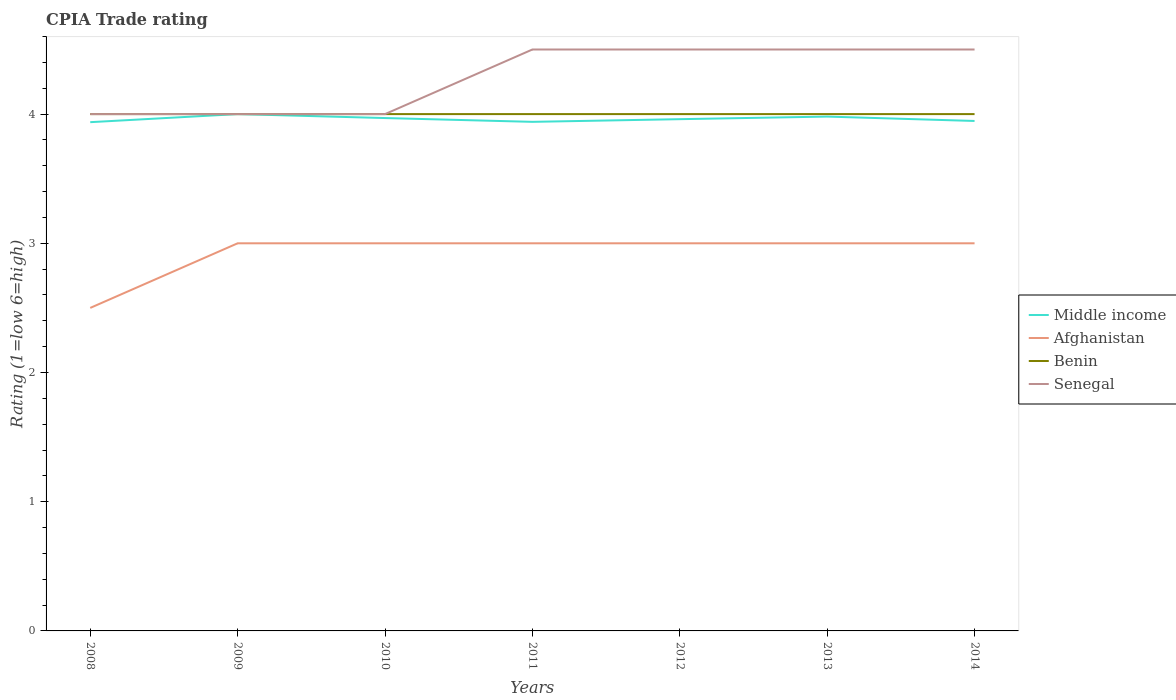How many different coloured lines are there?
Your answer should be very brief. 4. Does the line corresponding to Benin intersect with the line corresponding to Middle income?
Keep it short and to the point. Yes. Is the number of lines equal to the number of legend labels?
Offer a terse response. Yes. Across all years, what is the maximum CPIA rating in Senegal?
Your response must be concise. 4. In which year was the CPIA rating in Afghanistan maximum?
Your response must be concise. 2008. What is the difference between the highest and the second highest CPIA rating in Benin?
Your response must be concise. 0. What is the difference between the highest and the lowest CPIA rating in Middle income?
Provide a succinct answer. 3. Is the CPIA rating in Senegal strictly greater than the CPIA rating in Afghanistan over the years?
Your response must be concise. No. Does the graph contain any zero values?
Ensure brevity in your answer.  No. Where does the legend appear in the graph?
Provide a short and direct response. Center right. How many legend labels are there?
Provide a short and direct response. 4. How are the legend labels stacked?
Provide a short and direct response. Vertical. What is the title of the graph?
Provide a short and direct response. CPIA Trade rating. What is the label or title of the X-axis?
Your response must be concise. Years. What is the Rating (1=low 6=high) in Middle income in 2008?
Make the answer very short. 3.94. What is the Rating (1=low 6=high) in Afghanistan in 2008?
Make the answer very short. 2.5. What is the Rating (1=low 6=high) of Middle income in 2009?
Provide a succinct answer. 4. What is the Rating (1=low 6=high) of Afghanistan in 2009?
Provide a short and direct response. 3. What is the Rating (1=low 6=high) in Benin in 2009?
Provide a succinct answer. 4. What is the Rating (1=low 6=high) of Senegal in 2009?
Provide a succinct answer. 4. What is the Rating (1=low 6=high) in Middle income in 2010?
Provide a short and direct response. 3.97. What is the Rating (1=low 6=high) of Afghanistan in 2010?
Keep it short and to the point. 3. What is the Rating (1=low 6=high) in Middle income in 2011?
Your answer should be compact. 3.94. What is the Rating (1=low 6=high) in Afghanistan in 2011?
Ensure brevity in your answer.  3. What is the Rating (1=low 6=high) of Senegal in 2011?
Offer a terse response. 4.5. What is the Rating (1=low 6=high) of Middle income in 2012?
Your response must be concise. 3.96. What is the Rating (1=low 6=high) in Afghanistan in 2012?
Keep it short and to the point. 3. What is the Rating (1=low 6=high) of Benin in 2012?
Provide a succinct answer. 4. What is the Rating (1=low 6=high) of Middle income in 2013?
Your answer should be compact. 3.98. What is the Rating (1=low 6=high) in Benin in 2013?
Your answer should be very brief. 4. What is the Rating (1=low 6=high) of Middle income in 2014?
Offer a terse response. 3.95. What is the Rating (1=low 6=high) in Benin in 2014?
Provide a short and direct response. 4. What is the Rating (1=low 6=high) of Senegal in 2014?
Give a very brief answer. 4.5. Across all years, what is the maximum Rating (1=low 6=high) in Middle income?
Make the answer very short. 4. Across all years, what is the minimum Rating (1=low 6=high) of Middle income?
Your answer should be very brief. 3.94. Across all years, what is the minimum Rating (1=low 6=high) in Senegal?
Offer a very short reply. 4. What is the total Rating (1=low 6=high) of Middle income in the graph?
Make the answer very short. 27.74. What is the difference between the Rating (1=low 6=high) in Middle income in 2008 and that in 2009?
Keep it short and to the point. -0.06. What is the difference between the Rating (1=low 6=high) in Afghanistan in 2008 and that in 2009?
Your answer should be compact. -0.5. What is the difference between the Rating (1=low 6=high) of Middle income in 2008 and that in 2010?
Offer a terse response. -0.03. What is the difference between the Rating (1=low 6=high) of Afghanistan in 2008 and that in 2010?
Your answer should be very brief. -0.5. What is the difference between the Rating (1=low 6=high) in Benin in 2008 and that in 2010?
Offer a terse response. 0. What is the difference between the Rating (1=low 6=high) of Senegal in 2008 and that in 2010?
Your response must be concise. 0. What is the difference between the Rating (1=low 6=high) of Middle income in 2008 and that in 2011?
Your answer should be very brief. -0. What is the difference between the Rating (1=low 6=high) of Middle income in 2008 and that in 2012?
Provide a succinct answer. -0.02. What is the difference between the Rating (1=low 6=high) in Benin in 2008 and that in 2012?
Offer a terse response. 0. What is the difference between the Rating (1=low 6=high) in Middle income in 2008 and that in 2013?
Your answer should be compact. -0.04. What is the difference between the Rating (1=low 6=high) in Afghanistan in 2008 and that in 2013?
Offer a very short reply. -0.5. What is the difference between the Rating (1=low 6=high) of Benin in 2008 and that in 2013?
Make the answer very short. 0. What is the difference between the Rating (1=low 6=high) of Middle income in 2008 and that in 2014?
Your answer should be compact. -0.01. What is the difference between the Rating (1=low 6=high) of Afghanistan in 2008 and that in 2014?
Your answer should be compact. -0.5. What is the difference between the Rating (1=low 6=high) of Middle income in 2009 and that in 2010?
Make the answer very short. 0.03. What is the difference between the Rating (1=low 6=high) of Benin in 2009 and that in 2010?
Your answer should be compact. 0. What is the difference between the Rating (1=low 6=high) of Benin in 2009 and that in 2011?
Offer a terse response. 0. What is the difference between the Rating (1=low 6=high) in Senegal in 2009 and that in 2011?
Your response must be concise. -0.5. What is the difference between the Rating (1=low 6=high) in Middle income in 2009 and that in 2012?
Your response must be concise. 0.04. What is the difference between the Rating (1=low 6=high) of Afghanistan in 2009 and that in 2012?
Provide a succinct answer. 0. What is the difference between the Rating (1=low 6=high) of Senegal in 2009 and that in 2012?
Keep it short and to the point. -0.5. What is the difference between the Rating (1=low 6=high) in Middle income in 2009 and that in 2013?
Offer a terse response. 0.02. What is the difference between the Rating (1=low 6=high) of Afghanistan in 2009 and that in 2013?
Keep it short and to the point. 0. What is the difference between the Rating (1=low 6=high) in Benin in 2009 and that in 2013?
Provide a short and direct response. 0. What is the difference between the Rating (1=low 6=high) in Senegal in 2009 and that in 2013?
Keep it short and to the point. -0.5. What is the difference between the Rating (1=low 6=high) of Middle income in 2009 and that in 2014?
Offer a terse response. 0.05. What is the difference between the Rating (1=low 6=high) of Afghanistan in 2009 and that in 2014?
Offer a very short reply. 0. What is the difference between the Rating (1=low 6=high) in Benin in 2009 and that in 2014?
Offer a terse response. 0. What is the difference between the Rating (1=low 6=high) in Senegal in 2009 and that in 2014?
Provide a short and direct response. -0.5. What is the difference between the Rating (1=low 6=high) of Middle income in 2010 and that in 2011?
Provide a succinct answer. 0.03. What is the difference between the Rating (1=low 6=high) in Benin in 2010 and that in 2011?
Your answer should be compact. 0. What is the difference between the Rating (1=low 6=high) of Senegal in 2010 and that in 2011?
Ensure brevity in your answer.  -0.5. What is the difference between the Rating (1=low 6=high) in Middle income in 2010 and that in 2012?
Offer a very short reply. 0.01. What is the difference between the Rating (1=low 6=high) in Senegal in 2010 and that in 2012?
Ensure brevity in your answer.  -0.5. What is the difference between the Rating (1=low 6=high) of Middle income in 2010 and that in 2013?
Your response must be concise. -0.01. What is the difference between the Rating (1=low 6=high) in Afghanistan in 2010 and that in 2013?
Ensure brevity in your answer.  0. What is the difference between the Rating (1=low 6=high) of Benin in 2010 and that in 2013?
Your answer should be very brief. 0. What is the difference between the Rating (1=low 6=high) of Middle income in 2010 and that in 2014?
Your answer should be very brief. 0.02. What is the difference between the Rating (1=low 6=high) in Afghanistan in 2010 and that in 2014?
Your response must be concise. 0. What is the difference between the Rating (1=low 6=high) in Benin in 2010 and that in 2014?
Your answer should be very brief. 0. What is the difference between the Rating (1=low 6=high) in Senegal in 2010 and that in 2014?
Keep it short and to the point. -0.5. What is the difference between the Rating (1=low 6=high) of Middle income in 2011 and that in 2012?
Provide a succinct answer. -0.02. What is the difference between the Rating (1=low 6=high) of Senegal in 2011 and that in 2012?
Offer a terse response. 0. What is the difference between the Rating (1=low 6=high) in Middle income in 2011 and that in 2013?
Your answer should be compact. -0.04. What is the difference between the Rating (1=low 6=high) in Afghanistan in 2011 and that in 2013?
Keep it short and to the point. 0. What is the difference between the Rating (1=low 6=high) of Middle income in 2011 and that in 2014?
Offer a terse response. -0.01. What is the difference between the Rating (1=low 6=high) of Senegal in 2011 and that in 2014?
Provide a succinct answer. 0. What is the difference between the Rating (1=low 6=high) in Middle income in 2012 and that in 2013?
Offer a terse response. -0.02. What is the difference between the Rating (1=low 6=high) in Afghanistan in 2012 and that in 2013?
Provide a succinct answer. 0. What is the difference between the Rating (1=low 6=high) of Benin in 2012 and that in 2013?
Offer a very short reply. 0. What is the difference between the Rating (1=low 6=high) of Senegal in 2012 and that in 2013?
Provide a short and direct response. 0. What is the difference between the Rating (1=low 6=high) in Middle income in 2012 and that in 2014?
Your answer should be very brief. 0.01. What is the difference between the Rating (1=low 6=high) of Benin in 2012 and that in 2014?
Offer a terse response. 0. What is the difference between the Rating (1=low 6=high) in Middle income in 2013 and that in 2014?
Your answer should be compact. 0.03. What is the difference between the Rating (1=low 6=high) of Afghanistan in 2013 and that in 2014?
Your response must be concise. 0. What is the difference between the Rating (1=low 6=high) in Benin in 2013 and that in 2014?
Ensure brevity in your answer.  0. What is the difference between the Rating (1=low 6=high) of Middle income in 2008 and the Rating (1=low 6=high) of Afghanistan in 2009?
Your answer should be very brief. 0.94. What is the difference between the Rating (1=low 6=high) in Middle income in 2008 and the Rating (1=low 6=high) in Benin in 2009?
Provide a short and direct response. -0.06. What is the difference between the Rating (1=low 6=high) in Middle income in 2008 and the Rating (1=low 6=high) in Senegal in 2009?
Offer a terse response. -0.06. What is the difference between the Rating (1=low 6=high) in Afghanistan in 2008 and the Rating (1=low 6=high) in Senegal in 2009?
Your response must be concise. -1.5. What is the difference between the Rating (1=low 6=high) in Middle income in 2008 and the Rating (1=low 6=high) in Afghanistan in 2010?
Your response must be concise. 0.94. What is the difference between the Rating (1=low 6=high) of Middle income in 2008 and the Rating (1=low 6=high) of Benin in 2010?
Offer a terse response. -0.06. What is the difference between the Rating (1=low 6=high) in Middle income in 2008 and the Rating (1=low 6=high) in Senegal in 2010?
Make the answer very short. -0.06. What is the difference between the Rating (1=low 6=high) of Benin in 2008 and the Rating (1=low 6=high) of Senegal in 2010?
Offer a terse response. 0. What is the difference between the Rating (1=low 6=high) in Middle income in 2008 and the Rating (1=low 6=high) in Afghanistan in 2011?
Make the answer very short. 0.94. What is the difference between the Rating (1=low 6=high) of Middle income in 2008 and the Rating (1=low 6=high) of Benin in 2011?
Provide a short and direct response. -0.06. What is the difference between the Rating (1=low 6=high) of Middle income in 2008 and the Rating (1=low 6=high) of Senegal in 2011?
Your answer should be very brief. -0.56. What is the difference between the Rating (1=low 6=high) of Afghanistan in 2008 and the Rating (1=low 6=high) of Benin in 2011?
Offer a terse response. -1.5. What is the difference between the Rating (1=low 6=high) in Afghanistan in 2008 and the Rating (1=low 6=high) in Senegal in 2011?
Make the answer very short. -2. What is the difference between the Rating (1=low 6=high) in Middle income in 2008 and the Rating (1=low 6=high) in Benin in 2012?
Provide a short and direct response. -0.06. What is the difference between the Rating (1=low 6=high) of Middle income in 2008 and the Rating (1=low 6=high) of Senegal in 2012?
Keep it short and to the point. -0.56. What is the difference between the Rating (1=low 6=high) in Afghanistan in 2008 and the Rating (1=low 6=high) in Benin in 2012?
Give a very brief answer. -1.5. What is the difference between the Rating (1=low 6=high) in Middle income in 2008 and the Rating (1=low 6=high) in Benin in 2013?
Make the answer very short. -0.06. What is the difference between the Rating (1=low 6=high) of Middle income in 2008 and the Rating (1=low 6=high) of Senegal in 2013?
Your answer should be compact. -0.56. What is the difference between the Rating (1=low 6=high) of Afghanistan in 2008 and the Rating (1=low 6=high) of Benin in 2013?
Give a very brief answer. -1.5. What is the difference between the Rating (1=low 6=high) of Afghanistan in 2008 and the Rating (1=low 6=high) of Senegal in 2013?
Provide a short and direct response. -2. What is the difference between the Rating (1=low 6=high) of Benin in 2008 and the Rating (1=low 6=high) of Senegal in 2013?
Your answer should be compact. -0.5. What is the difference between the Rating (1=low 6=high) in Middle income in 2008 and the Rating (1=low 6=high) in Benin in 2014?
Your answer should be very brief. -0.06. What is the difference between the Rating (1=low 6=high) of Middle income in 2008 and the Rating (1=low 6=high) of Senegal in 2014?
Provide a short and direct response. -0.56. What is the difference between the Rating (1=low 6=high) of Afghanistan in 2008 and the Rating (1=low 6=high) of Senegal in 2014?
Make the answer very short. -2. What is the difference between the Rating (1=low 6=high) of Middle income in 2009 and the Rating (1=low 6=high) of Benin in 2010?
Give a very brief answer. 0. What is the difference between the Rating (1=low 6=high) of Middle income in 2009 and the Rating (1=low 6=high) of Senegal in 2010?
Provide a succinct answer. 0. What is the difference between the Rating (1=low 6=high) of Afghanistan in 2009 and the Rating (1=low 6=high) of Senegal in 2010?
Your response must be concise. -1. What is the difference between the Rating (1=low 6=high) in Benin in 2009 and the Rating (1=low 6=high) in Senegal in 2010?
Your answer should be compact. 0. What is the difference between the Rating (1=low 6=high) in Middle income in 2009 and the Rating (1=low 6=high) in Benin in 2011?
Provide a succinct answer. 0. What is the difference between the Rating (1=low 6=high) of Middle income in 2009 and the Rating (1=low 6=high) of Senegal in 2011?
Your response must be concise. -0.5. What is the difference between the Rating (1=low 6=high) in Afghanistan in 2009 and the Rating (1=low 6=high) in Senegal in 2011?
Your response must be concise. -1.5. What is the difference between the Rating (1=low 6=high) in Benin in 2009 and the Rating (1=low 6=high) in Senegal in 2011?
Offer a terse response. -0.5. What is the difference between the Rating (1=low 6=high) of Middle income in 2009 and the Rating (1=low 6=high) of Senegal in 2012?
Keep it short and to the point. -0.5. What is the difference between the Rating (1=low 6=high) in Afghanistan in 2009 and the Rating (1=low 6=high) in Senegal in 2012?
Your answer should be compact. -1.5. What is the difference between the Rating (1=low 6=high) of Benin in 2009 and the Rating (1=low 6=high) of Senegal in 2012?
Offer a terse response. -0.5. What is the difference between the Rating (1=low 6=high) of Middle income in 2009 and the Rating (1=low 6=high) of Afghanistan in 2013?
Provide a succinct answer. 1. What is the difference between the Rating (1=low 6=high) in Afghanistan in 2009 and the Rating (1=low 6=high) in Benin in 2013?
Provide a short and direct response. -1. What is the difference between the Rating (1=low 6=high) of Afghanistan in 2009 and the Rating (1=low 6=high) of Senegal in 2013?
Your answer should be very brief. -1.5. What is the difference between the Rating (1=low 6=high) in Middle income in 2009 and the Rating (1=low 6=high) in Benin in 2014?
Make the answer very short. 0. What is the difference between the Rating (1=low 6=high) in Middle income in 2009 and the Rating (1=low 6=high) in Senegal in 2014?
Keep it short and to the point. -0.5. What is the difference between the Rating (1=low 6=high) in Afghanistan in 2009 and the Rating (1=low 6=high) in Benin in 2014?
Your answer should be very brief. -1. What is the difference between the Rating (1=low 6=high) in Afghanistan in 2009 and the Rating (1=low 6=high) in Senegal in 2014?
Give a very brief answer. -1.5. What is the difference between the Rating (1=low 6=high) of Middle income in 2010 and the Rating (1=low 6=high) of Afghanistan in 2011?
Make the answer very short. 0.97. What is the difference between the Rating (1=low 6=high) of Middle income in 2010 and the Rating (1=low 6=high) of Benin in 2011?
Make the answer very short. -0.03. What is the difference between the Rating (1=low 6=high) in Middle income in 2010 and the Rating (1=low 6=high) in Senegal in 2011?
Provide a short and direct response. -0.53. What is the difference between the Rating (1=low 6=high) of Afghanistan in 2010 and the Rating (1=low 6=high) of Benin in 2011?
Make the answer very short. -1. What is the difference between the Rating (1=low 6=high) of Middle income in 2010 and the Rating (1=low 6=high) of Afghanistan in 2012?
Provide a succinct answer. 0.97. What is the difference between the Rating (1=low 6=high) in Middle income in 2010 and the Rating (1=low 6=high) in Benin in 2012?
Provide a short and direct response. -0.03. What is the difference between the Rating (1=low 6=high) in Middle income in 2010 and the Rating (1=low 6=high) in Senegal in 2012?
Your answer should be very brief. -0.53. What is the difference between the Rating (1=low 6=high) of Afghanistan in 2010 and the Rating (1=low 6=high) of Benin in 2012?
Your response must be concise. -1. What is the difference between the Rating (1=low 6=high) in Benin in 2010 and the Rating (1=low 6=high) in Senegal in 2012?
Your response must be concise. -0.5. What is the difference between the Rating (1=low 6=high) in Middle income in 2010 and the Rating (1=low 6=high) in Afghanistan in 2013?
Ensure brevity in your answer.  0.97. What is the difference between the Rating (1=low 6=high) of Middle income in 2010 and the Rating (1=low 6=high) of Benin in 2013?
Offer a terse response. -0.03. What is the difference between the Rating (1=low 6=high) of Middle income in 2010 and the Rating (1=low 6=high) of Senegal in 2013?
Keep it short and to the point. -0.53. What is the difference between the Rating (1=low 6=high) of Afghanistan in 2010 and the Rating (1=low 6=high) of Senegal in 2013?
Give a very brief answer. -1.5. What is the difference between the Rating (1=low 6=high) in Benin in 2010 and the Rating (1=low 6=high) in Senegal in 2013?
Keep it short and to the point. -0.5. What is the difference between the Rating (1=low 6=high) of Middle income in 2010 and the Rating (1=low 6=high) of Afghanistan in 2014?
Offer a very short reply. 0.97. What is the difference between the Rating (1=low 6=high) of Middle income in 2010 and the Rating (1=low 6=high) of Benin in 2014?
Offer a terse response. -0.03. What is the difference between the Rating (1=low 6=high) in Middle income in 2010 and the Rating (1=low 6=high) in Senegal in 2014?
Offer a very short reply. -0.53. What is the difference between the Rating (1=low 6=high) in Afghanistan in 2010 and the Rating (1=low 6=high) in Benin in 2014?
Your response must be concise. -1. What is the difference between the Rating (1=low 6=high) in Middle income in 2011 and the Rating (1=low 6=high) in Benin in 2012?
Your response must be concise. -0.06. What is the difference between the Rating (1=low 6=high) of Middle income in 2011 and the Rating (1=low 6=high) of Senegal in 2012?
Give a very brief answer. -0.56. What is the difference between the Rating (1=low 6=high) of Afghanistan in 2011 and the Rating (1=low 6=high) of Benin in 2012?
Make the answer very short. -1. What is the difference between the Rating (1=low 6=high) in Afghanistan in 2011 and the Rating (1=low 6=high) in Senegal in 2012?
Give a very brief answer. -1.5. What is the difference between the Rating (1=low 6=high) in Middle income in 2011 and the Rating (1=low 6=high) in Benin in 2013?
Your response must be concise. -0.06. What is the difference between the Rating (1=low 6=high) in Middle income in 2011 and the Rating (1=low 6=high) in Senegal in 2013?
Provide a succinct answer. -0.56. What is the difference between the Rating (1=low 6=high) in Benin in 2011 and the Rating (1=low 6=high) in Senegal in 2013?
Offer a very short reply. -0.5. What is the difference between the Rating (1=low 6=high) in Middle income in 2011 and the Rating (1=low 6=high) in Benin in 2014?
Your answer should be compact. -0.06. What is the difference between the Rating (1=low 6=high) in Middle income in 2011 and the Rating (1=low 6=high) in Senegal in 2014?
Your answer should be very brief. -0.56. What is the difference between the Rating (1=low 6=high) in Afghanistan in 2011 and the Rating (1=low 6=high) in Senegal in 2014?
Make the answer very short. -1.5. What is the difference between the Rating (1=low 6=high) in Benin in 2011 and the Rating (1=low 6=high) in Senegal in 2014?
Provide a succinct answer. -0.5. What is the difference between the Rating (1=low 6=high) of Middle income in 2012 and the Rating (1=low 6=high) of Afghanistan in 2013?
Ensure brevity in your answer.  0.96. What is the difference between the Rating (1=low 6=high) in Middle income in 2012 and the Rating (1=low 6=high) in Benin in 2013?
Provide a succinct answer. -0.04. What is the difference between the Rating (1=low 6=high) of Middle income in 2012 and the Rating (1=low 6=high) of Senegal in 2013?
Your answer should be very brief. -0.54. What is the difference between the Rating (1=low 6=high) of Afghanistan in 2012 and the Rating (1=low 6=high) of Senegal in 2013?
Your response must be concise. -1.5. What is the difference between the Rating (1=low 6=high) in Benin in 2012 and the Rating (1=low 6=high) in Senegal in 2013?
Offer a terse response. -0.5. What is the difference between the Rating (1=low 6=high) in Middle income in 2012 and the Rating (1=low 6=high) in Afghanistan in 2014?
Give a very brief answer. 0.96. What is the difference between the Rating (1=low 6=high) of Middle income in 2012 and the Rating (1=low 6=high) of Benin in 2014?
Make the answer very short. -0.04. What is the difference between the Rating (1=low 6=high) in Middle income in 2012 and the Rating (1=low 6=high) in Senegal in 2014?
Keep it short and to the point. -0.54. What is the difference between the Rating (1=low 6=high) in Afghanistan in 2012 and the Rating (1=low 6=high) in Benin in 2014?
Offer a very short reply. -1. What is the difference between the Rating (1=low 6=high) in Benin in 2012 and the Rating (1=low 6=high) in Senegal in 2014?
Provide a short and direct response. -0.5. What is the difference between the Rating (1=low 6=high) of Middle income in 2013 and the Rating (1=low 6=high) of Afghanistan in 2014?
Your answer should be very brief. 0.98. What is the difference between the Rating (1=low 6=high) of Middle income in 2013 and the Rating (1=low 6=high) of Benin in 2014?
Keep it short and to the point. -0.02. What is the difference between the Rating (1=low 6=high) of Middle income in 2013 and the Rating (1=low 6=high) of Senegal in 2014?
Your response must be concise. -0.52. What is the difference between the Rating (1=low 6=high) in Benin in 2013 and the Rating (1=low 6=high) in Senegal in 2014?
Provide a succinct answer. -0.5. What is the average Rating (1=low 6=high) of Middle income per year?
Offer a very short reply. 3.96. What is the average Rating (1=low 6=high) of Afghanistan per year?
Provide a succinct answer. 2.93. What is the average Rating (1=low 6=high) in Benin per year?
Make the answer very short. 4. What is the average Rating (1=low 6=high) in Senegal per year?
Offer a terse response. 4.29. In the year 2008, what is the difference between the Rating (1=low 6=high) in Middle income and Rating (1=low 6=high) in Afghanistan?
Offer a very short reply. 1.44. In the year 2008, what is the difference between the Rating (1=low 6=high) of Middle income and Rating (1=low 6=high) of Benin?
Give a very brief answer. -0.06. In the year 2008, what is the difference between the Rating (1=low 6=high) in Middle income and Rating (1=low 6=high) in Senegal?
Provide a succinct answer. -0.06. In the year 2008, what is the difference between the Rating (1=low 6=high) in Afghanistan and Rating (1=low 6=high) in Benin?
Your response must be concise. -1.5. In the year 2008, what is the difference between the Rating (1=low 6=high) of Afghanistan and Rating (1=low 6=high) of Senegal?
Provide a short and direct response. -1.5. In the year 2009, what is the difference between the Rating (1=low 6=high) of Middle income and Rating (1=low 6=high) of Afghanistan?
Give a very brief answer. 1. In the year 2009, what is the difference between the Rating (1=low 6=high) of Afghanistan and Rating (1=low 6=high) of Benin?
Your answer should be very brief. -1. In the year 2009, what is the difference between the Rating (1=low 6=high) in Afghanistan and Rating (1=low 6=high) in Senegal?
Offer a terse response. -1. In the year 2009, what is the difference between the Rating (1=low 6=high) in Benin and Rating (1=low 6=high) in Senegal?
Your answer should be very brief. 0. In the year 2010, what is the difference between the Rating (1=low 6=high) in Middle income and Rating (1=low 6=high) in Afghanistan?
Give a very brief answer. 0.97. In the year 2010, what is the difference between the Rating (1=low 6=high) of Middle income and Rating (1=low 6=high) of Benin?
Give a very brief answer. -0.03. In the year 2010, what is the difference between the Rating (1=low 6=high) in Middle income and Rating (1=low 6=high) in Senegal?
Make the answer very short. -0.03. In the year 2010, what is the difference between the Rating (1=low 6=high) of Afghanistan and Rating (1=low 6=high) of Benin?
Provide a succinct answer. -1. In the year 2011, what is the difference between the Rating (1=low 6=high) in Middle income and Rating (1=low 6=high) in Afghanistan?
Your response must be concise. 0.94. In the year 2011, what is the difference between the Rating (1=low 6=high) in Middle income and Rating (1=low 6=high) in Benin?
Offer a very short reply. -0.06. In the year 2011, what is the difference between the Rating (1=low 6=high) of Middle income and Rating (1=low 6=high) of Senegal?
Provide a short and direct response. -0.56. In the year 2011, what is the difference between the Rating (1=low 6=high) in Afghanistan and Rating (1=low 6=high) in Benin?
Provide a succinct answer. -1. In the year 2012, what is the difference between the Rating (1=low 6=high) in Middle income and Rating (1=low 6=high) in Afghanistan?
Your answer should be compact. 0.96. In the year 2012, what is the difference between the Rating (1=low 6=high) of Middle income and Rating (1=low 6=high) of Benin?
Make the answer very short. -0.04. In the year 2012, what is the difference between the Rating (1=low 6=high) of Middle income and Rating (1=low 6=high) of Senegal?
Keep it short and to the point. -0.54. In the year 2012, what is the difference between the Rating (1=low 6=high) of Afghanistan and Rating (1=low 6=high) of Senegal?
Offer a terse response. -1.5. In the year 2012, what is the difference between the Rating (1=low 6=high) of Benin and Rating (1=low 6=high) of Senegal?
Your response must be concise. -0.5. In the year 2013, what is the difference between the Rating (1=low 6=high) in Middle income and Rating (1=low 6=high) in Afghanistan?
Provide a succinct answer. 0.98. In the year 2013, what is the difference between the Rating (1=low 6=high) in Middle income and Rating (1=low 6=high) in Benin?
Provide a short and direct response. -0.02. In the year 2013, what is the difference between the Rating (1=low 6=high) of Middle income and Rating (1=low 6=high) of Senegal?
Provide a succinct answer. -0.52. In the year 2013, what is the difference between the Rating (1=low 6=high) of Afghanistan and Rating (1=low 6=high) of Benin?
Your answer should be compact. -1. In the year 2013, what is the difference between the Rating (1=low 6=high) in Afghanistan and Rating (1=low 6=high) in Senegal?
Give a very brief answer. -1.5. In the year 2013, what is the difference between the Rating (1=low 6=high) of Benin and Rating (1=low 6=high) of Senegal?
Your answer should be very brief. -0.5. In the year 2014, what is the difference between the Rating (1=low 6=high) of Middle income and Rating (1=low 6=high) of Afghanistan?
Make the answer very short. 0.95. In the year 2014, what is the difference between the Rating (1=low 6=high) of Middle income and Rating (1=low 6=high) of Benin?
Your response must be concise. -0.05. In the year 2014, what is the difference between the Rating (1=low 6=high) of Middle income and Rating (1=low 6=high) of Senegal?
Your answer should be compact. -0.55. In the year 2014, what is the difference between the Rating (1=low 6=high) in Benin and Rating (1=low 6=high) in Senegal?
Make the answer very short. -0.5. What is the ratio of the Rating (1=low 6=high) in Middle income in 2008 to that in 2009?
Your answer should be compact. 0.98. What is the ratio of the Rating (1=low 6=high) in Afghanistan in 2008 to that in 2009?
Provide a succinct answer. 0.83. What is the ratio of the Rating (1=low 6=high) of Benin in 2008 to that in 2009?
Offer a very short reply. 1. What is the ratio of the Rating (1=low 6=high) of Afghanistan in 2008 to that in 2010?
Ensure brevity in your answer.  0.83. What is the ratio of the Rating (1=low 6=high) in Middle income in 2008 to that in 2011?
Your response must be concise. 1. What is the ratio of the Rating (1=low 6=high) of Benin in 2008 to that in 2011?
Ensure brevity in your answer.  1. What is the ratio of the Rating (1=low 6=high) of Senegal in 2008 to that in 2011?
Make the answer very short. 0.89. What is the ratio of the Rating (1=low 6=high) of Afghanistan in 2008 to that in 2012?
Ensure brevity in your answer.  0.83. What is the ratio of the Rating (1=low 6=high) of Middle income in 2008 to that in 2013?
Your response must be concise. 0.99. What is the ratio of the Rating (1=low 6=high) of Senegal in 2008 to that in 2013?
Provide a short and direct response. 0.89. What is the ratio of the Rating (1=low 6=high) in Afghanistan in 2008 to that in 2014?
Offer a very short reply. 0.83. What is the ratio of the Rating (1=low 6=high) in Benin in 2008 to that in 2014?
Keep it short and to the point. 1. What is the ratio of the Rating (1=low 6=high) of Senegal in 2008 to that in 2014?
Offer a terse response. 0.89. What is the ratio of the Rating (1=low 6=high) in Middle income in 2009 to that in 2010?
Keep it short and to the point. 1.01. What is the ratio of the Rating (1=low 6=high) in Senegal in 2009 to that in 2010?
Ensure brevity in your answer.  1. What is the ratio of the Rating (1=low 6=high) of Middle income in 2009 to that in 2011?
Ensure brevity in your answer.  1.02. What is the ratio of the Rating (1=low 6=high) of Afghanistan in 2009 to that in 2011?
Give a very brief answer. 1. What is the ratio of the Rating (1=low 6=high) of Benin in 2009 to that in 2011?
Your answer should be very brief. 1. What is the ratio of the Rating (1=low 6=high) in Senegal in 2009 to that in 2011?
Give a very brief answer. 0.89. What is the ratio of the Rating (1=low 6=high) in Middle income in 2009 to that in 2012?
Your response must be concise. 1.01. What is the ratio of the Rating (1=low 6=high) of Afghanistan in 2009 to that in 2012?
Provide a succinct answer. 1. What is the ratio of the Rating (1=low 6=high) of Benin in 2009 to that in 2012?
Ensure brevity in your answer.  1. What is the ratio of the Rating (1=low 6=high) in Middle income in 2009 to that in 2013?
Your response must be concise. 1. What is the ratio of the Rating (1=low 6=high) in Afghanistan in 2009 to that in 2013?
Offer a very short reply. 1. What is the ratio of the Rating (1=low 6=high) in Middle income in 2009 to that in 2014?
Your answer should be compact. 1.01. What is the ratio of the Rating (1=low 6=high) of Benin in 2009 to that in 2014?
Offer a very short reply. 1. What is the ratio of the Rating (1=low 6=high) in Senegal in 2009 to that in 2014?
Keep it short and to the point. 0.89. What is the ratio of the Rating (1=low 6=high) of Middle income in 2010 to that in 2011?
Offer a very short reply. 1.01. What is the ratio of the Rating (1=low 6=high) of Afghanistan in 2010 to that in 2011?
Your answer should be very brief. 1. What is the ratio of the Rating (1=low 6=high) of Senegal in 2010 to that in 2011?
Make the answer very short. 0.89. What is the ratio of the Rating (1=low 6=high) of Middle income in 2010 to that in 2012?
Your answer should be compact. 1. What is the ratio of the Rating (1=low 6=high) in Afghanistan in 2010 to that in 2012?
Provide a succinct answer. 1. What is the ratio of the Rating (1=low 6=high) in Benin in 2010 to that in 2012?
Offer a very short reply. 1. What is the ratio of the Rating (1=low 6=high) in Middle income in 2010 to that in 2013?
Your answer should be compact. 1. What is the ratio of the Rating (1=low 6=high) in Senegal in 2010 to that in 2013?
Give a very brief answer. 0.89. What is the ratio of the Rating (1=low 6=high) of Middle income in 2010 to that in 2014?
Offer a very short reply. 1.01. What is the ratio of the Rating (1=low 6=high) of Benin in 2010 to that in 2014?
Your response must be concise. 1. What is the ratio of the Rating (1=low 6=high) of Middle income in 2011 to that in 2012?
Your response must be concise. 0.99. What is the ratio of the Rating (1=low 6=high) in Afghanistan in 2011 to that in 2012?
Provide a succinct answer. 1. What is the ratio of the Rating (1=low 6=high) in Senegal in 2011 to that in 2014?
Ensure brevity in your answer.  1. What is the ratio of the Rating (1=low 6=high) in Middle income in 2012 to that in 2013?
Your response must be concise. 0.99. What is the ratio of the Rating (1=low 6=high) in Senegal in 2012 to that in 2013?
Offer a terse response. 1. What is the ratio of the Rating (1=low 6=high) in Middle income in 2012 to that in 2014?
Offer a terse response. 1. What is the ratio of the Rating (1=low 6=high) in Afghanistan in 2012 to that in 2014?
Your answer should be compact. 1. What is the ratio of the Rating (1=low 6=high) in Middle income in 2013 to that in 2014?
Your response must be concise. 1.01. What is the ratio of the Rating (1=low 6=high) of Benin in 2013 to that in 2014?
Offer a terse response. 1. What is the difference between the highest and the second highest Rating (1=low 6=high) in Middle income?
Give a very brief answer. 0.02. What is the difference between the highest and the lowest Rating (1=low 6=high) of Middle income?
Keep it short and to the point. 0.06. What is the difference between the highest and the lowest Rating (1=low 6=high) in Afghanistan?
Offer a terse response. 0.5. What is the difference between the highest and the lowest Rating (1=low 6=high) in Benin?
Make the answer very short. 0. 